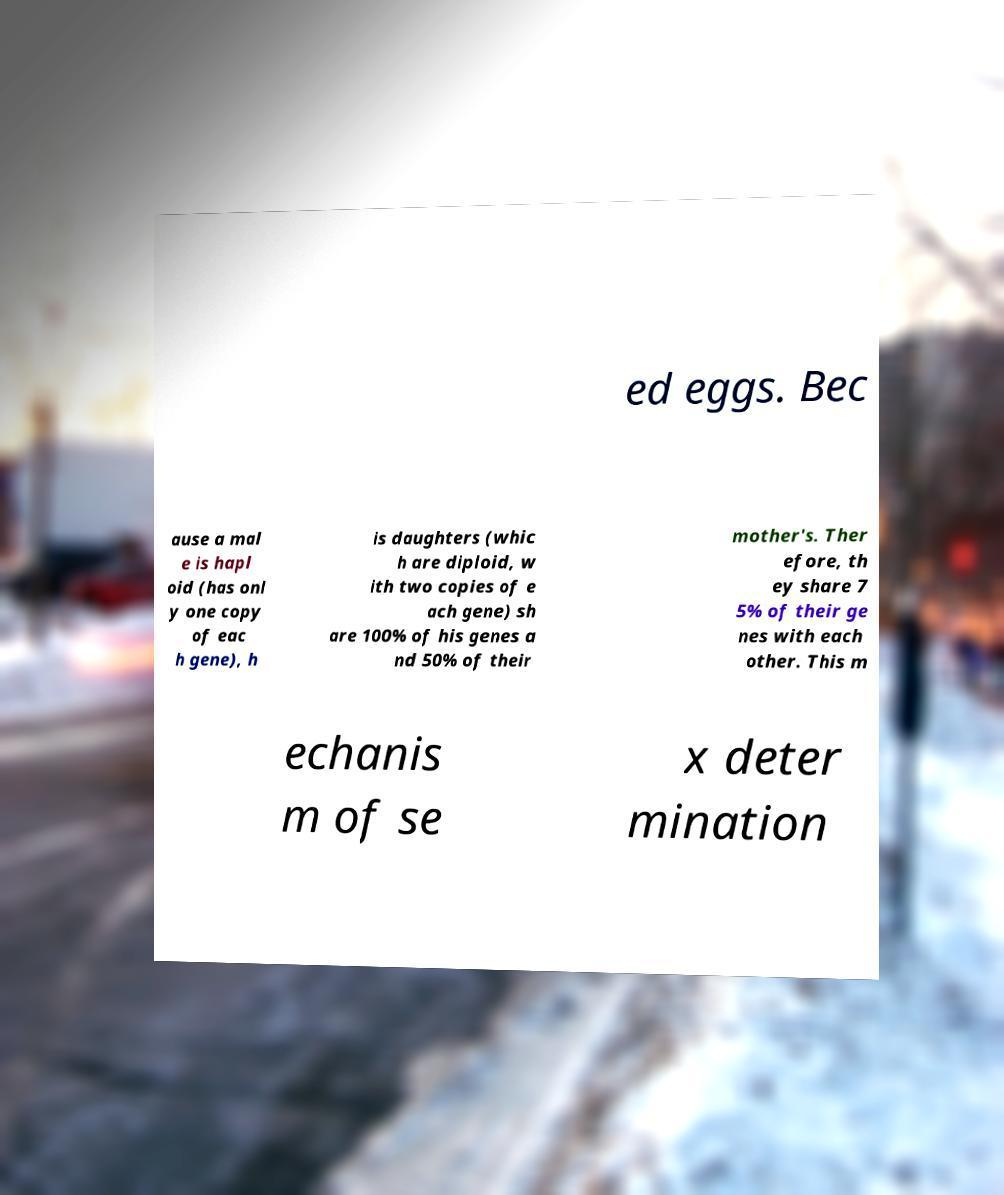I need the written content from this picture converted into text. Can you do that? ed eggs. Bec ause a mal e is hapl oid (has onl y one copy of eac h gene), h is daughters (whic h are diploid, w ith two copies of e ach gene) sh are 100% of his genes a nd 50% of their mother's. Ther efore, th ey share 7 5% of their ge nes with each other. This m echanis m of se x deter mination 